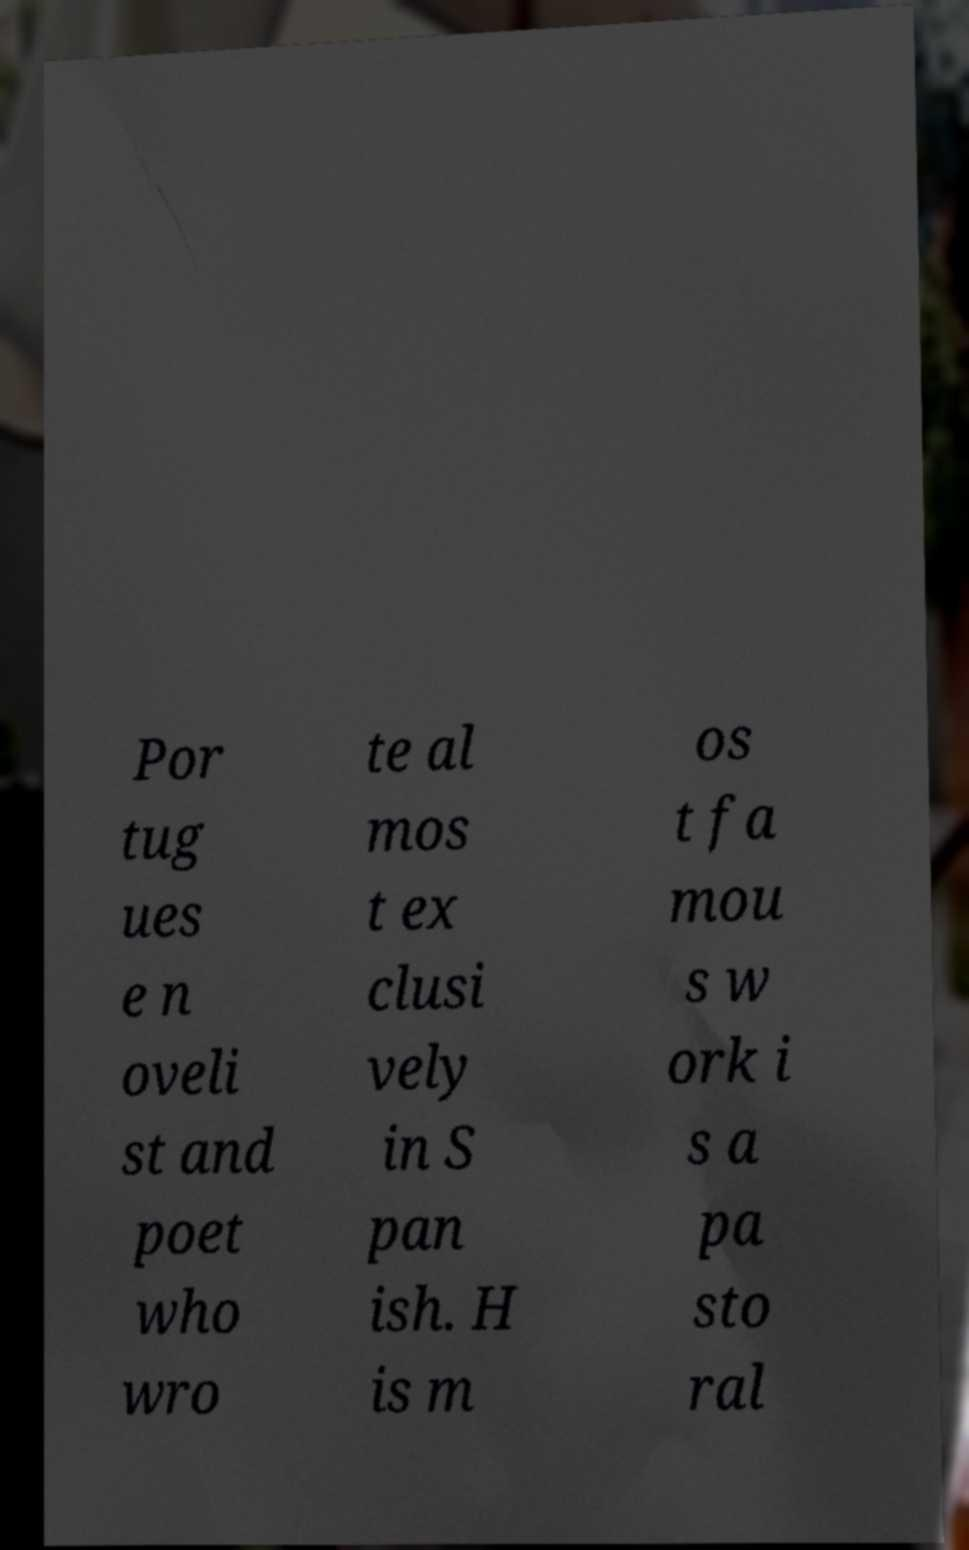Can you read and provide the text displayed in the image?This photo seems to have some interesting text. Can you extract and type it out for me? Por tug ues e n oveli st and poet who wro te al mos t ex clusi vely in S pan ish. H is m os t fa mou s w ork i s a pa sto ral 